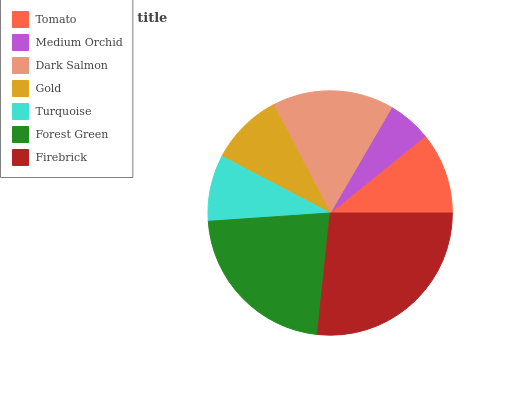Is Medium Orchid the minimum?
Answer yes or no. Yes. Is Firebrick the maximum?
Answer yes or no. Yes. Is Dark Salmon the minimum?
Answer yes or no. No. Is Dark Salmon the maximum?
Answer yes or no. No. Is Dark Salmon greater than Medium Orchid?
Answer yes or no. Yes. Is Medium Orchid less than Dark Salmon?
Answer yes or no. Yes. Is Medium Orchid greater than Dark Salmon?
Answer yes or no. No. Is Dark Salmon less than Medium Orchid?
Answer yes or no. No. Is Tomato the high median?
Answer yes or no. Yes. Is Tomato the low median?
Answer yes or no. Yes. Is Firebrick the high median?
Answer yes or no. No. Is Medium Orchid the low median?
Answer yes or no. No. 